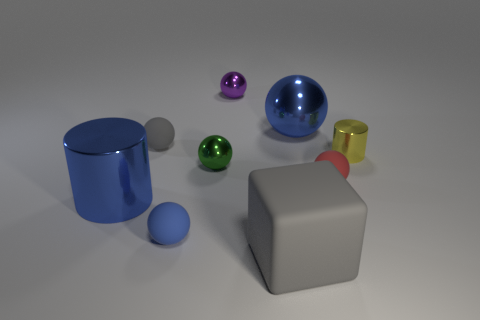Subtract all red balls. How many balls are left? 5 Subtract all small green metallic spheres. How many spheres are left? 5 Subtract all yellow spheres. Subtract all brown cubes. How many spheres are left? 6 Add 1 yellow cylinders. How many objects exist? 10 Subtract all cylinders. How many objects are left? 7 Subtract 0 brown cubes. How many objects are left? 9 Subtract all gray cylinders. Subtract all yellow shiny cylinders. How many objects are left? 8 Add 7 red rubber spheres. How many red rubber spheres are left? 8 Add 5 metal spheres. How many metal spheres exist? 8 